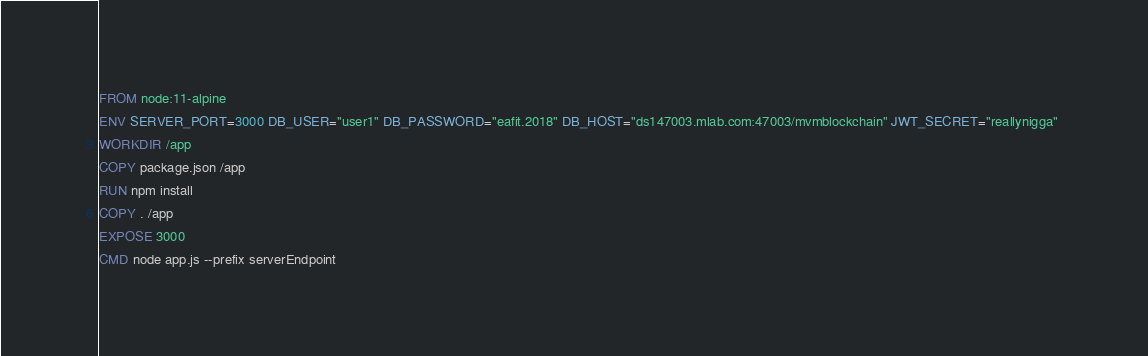<code> <loc_0><loc_0><loc_500><loc_500><_Dockerfile_>FROM node:11-alpine
ENV SERVER_PORT=3000 DB_USER="user1" DB_PASSWORD="eafit.2018" DB_HOST="ds147003.mlab.com:47003/mvmblockchain" JWT_SECRET="reallynigga" 
WORKDIR /app
COPY package.json /app
RUN npm install
COPY . /app
EXPOSE 3000
CMD node app.js --prefix serverEndpoint</code> 